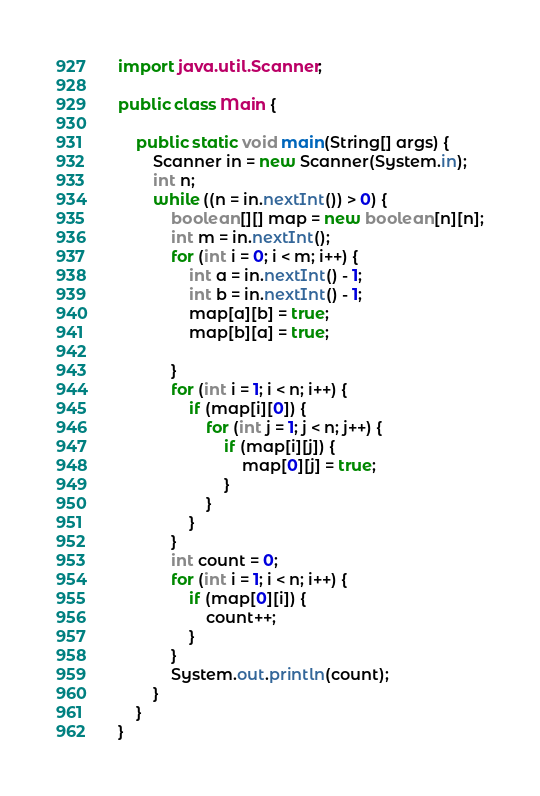<code> <loc_0><loc_0><loc_500><loc_500><_Java_>import java.util.Scanner;

public class Main {

	public static void main(String[] args) {
		Scanner in = new Scanner(System.in);
		int n;
		while ((n = in.nextInt()) > 0) {
			boolean[][] map = new boolean[n][n];
			int m = in.nextInt();
			for (int i = 0; i < m; i++) {
				int a = in.nextInt() - 1;
				int b = in.nextInt() - 1;
				map[a][b] = true;
				map[b][a] = true;

			}
			for (int i = 1; i < n; i++) {
				if (map[i][0]) {
					for (int j = 1; j < n; j++) {
						if (map[i][j]) {
							map[0][j] = true;
						}
					}
				}
			}
			int count = 0;
			for (int i = 1; i < n; i++) {
				if (map[0][i]) {
					count++;
				}
			}
			System.out.println(count);
		}
	}
}</code> 